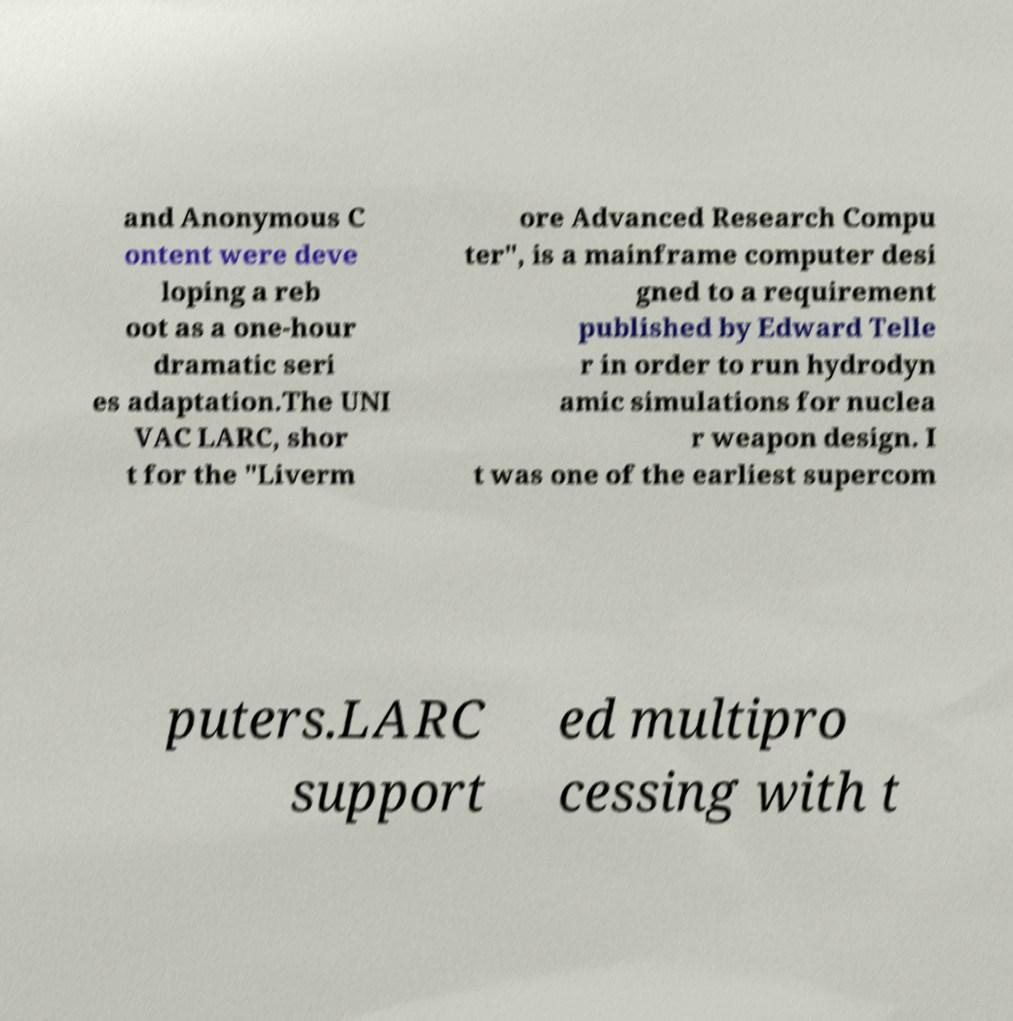Can you accurately transcribe the text from the provided image for me? and Anonymous C ontent were deve loping a reb oot as a one-hour dramatic seri es adaptation.The UNI VAC LARC, shor t for the "Liverm ore Advanced Research Compu ter", is a mainframe computer desi gned to a requirement published by Edward Telle r in order to run hydrodyn amic simulations for nuclea r weapon design. I t was one of the earliest supercom puters.LARC support ed multipro cessing with t 